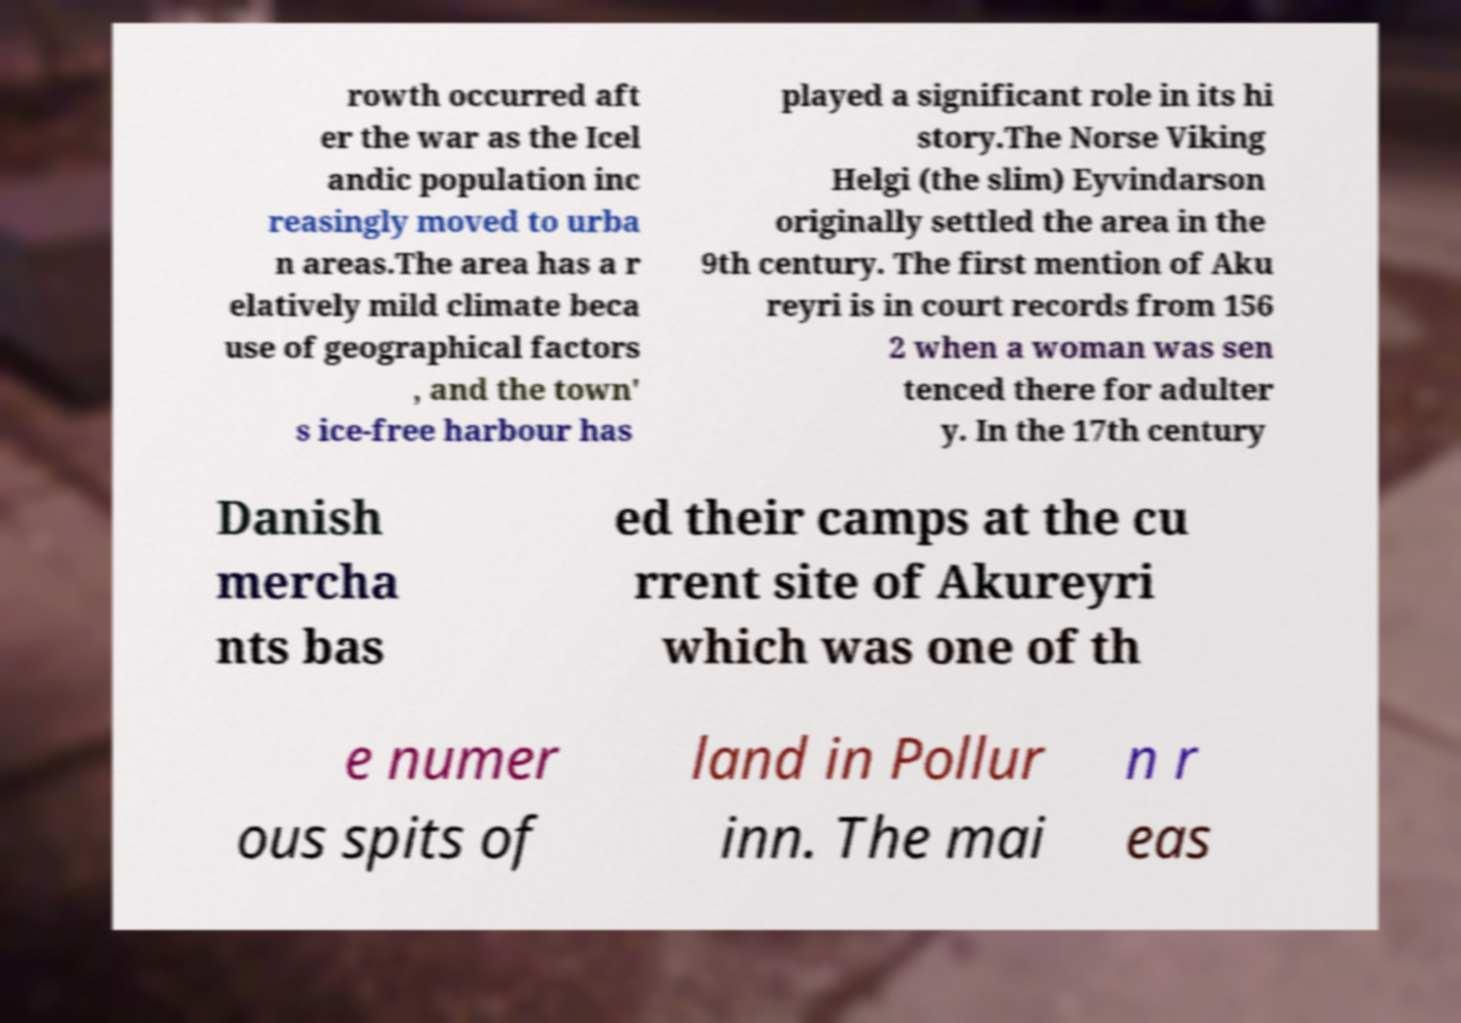For documentation purposes, I need the text within this image transcribed. Could you provide that? rowth occurred aft er the war as the Icel andic population inc reasingly moved to urba n areas.The area has a r elatively mild climate beca use of geographical factors , and the town' s ice-free harbour has played a significant role in its hi story.The Norse Viking Helgi (the slim) Eyvindarson originally settled the area in the 9th century. The first mention of Aku reyri is in court records from 156 2 when a woman was sen tenced there for adulter y. In the 17th century Danish mercha nts bas ed their camps at the cu rrent site of Akureyri which was one of th e numer ous spits of land in Pollur inn. The mai n r eas 